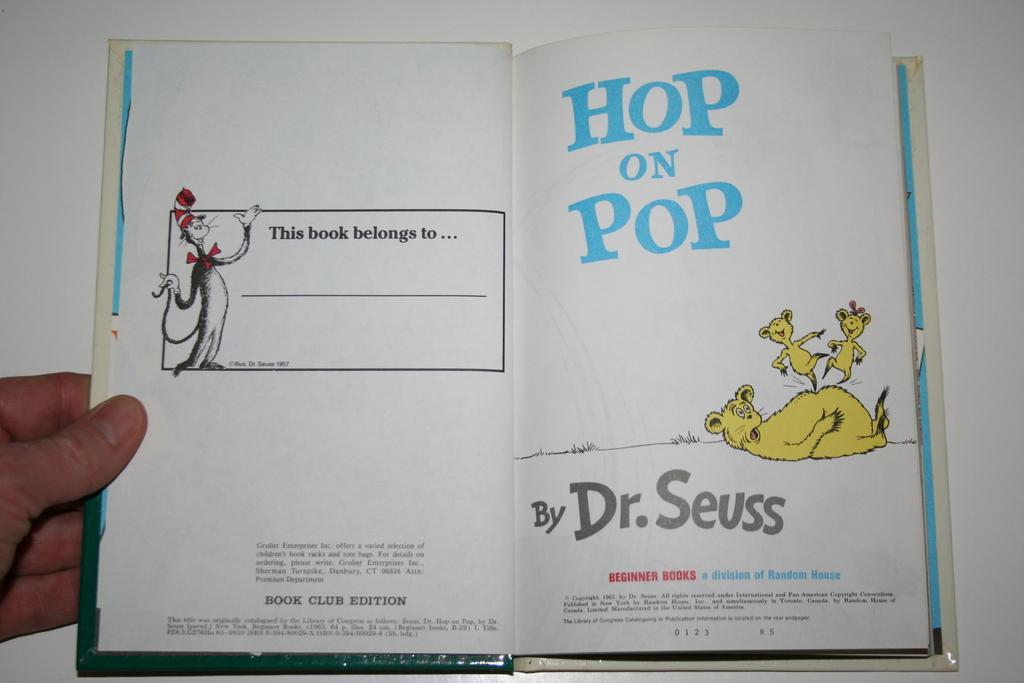Could you give a brief overview of what you see in this image? In this picture there is a person holding the book. In the book there are pictures of animals and there is a text. At the bottom there is a white background. 